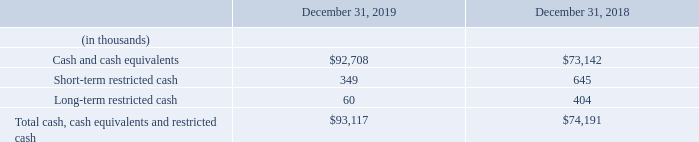7. Balance Sheet Details
Cash, cash equivalents, and restricted cash consist of the following:
As of December 31, 2019 and December 31, 2018, cash and cash equivalents included $20.4 million and $0 of money market funds, respectively. As of December 31, 2019 and 2018, the Company has restricted cash of $0.4 million and $1.0 million, respectively. The cash is restricted in connection with guarantees for certain import duties and office leases.
What was the money market frauds in 2019 and 2018? $20.4 million, $0. In what respect is cash restricted? Restricted in connection with guarantees for certain import duties and office leases. What was the Short-term restricted cash in 2019?
Answer scale should be: thousand. 349. What was the change in the cash and cash equivalents from 2018 to 2019?
Answer scale should be: thousand. 92,708 - 73,142
Answer: 19566. What is the average Short-term restricted cash for 2018 and 2019?
Answer scale should be: thousand. (349 + 645) / 2
Answer: 497. In which year was Long-term restricted cash less than 100 thousands? Locate and analyze long-term restricted cash in row 5
answer: 2019. 